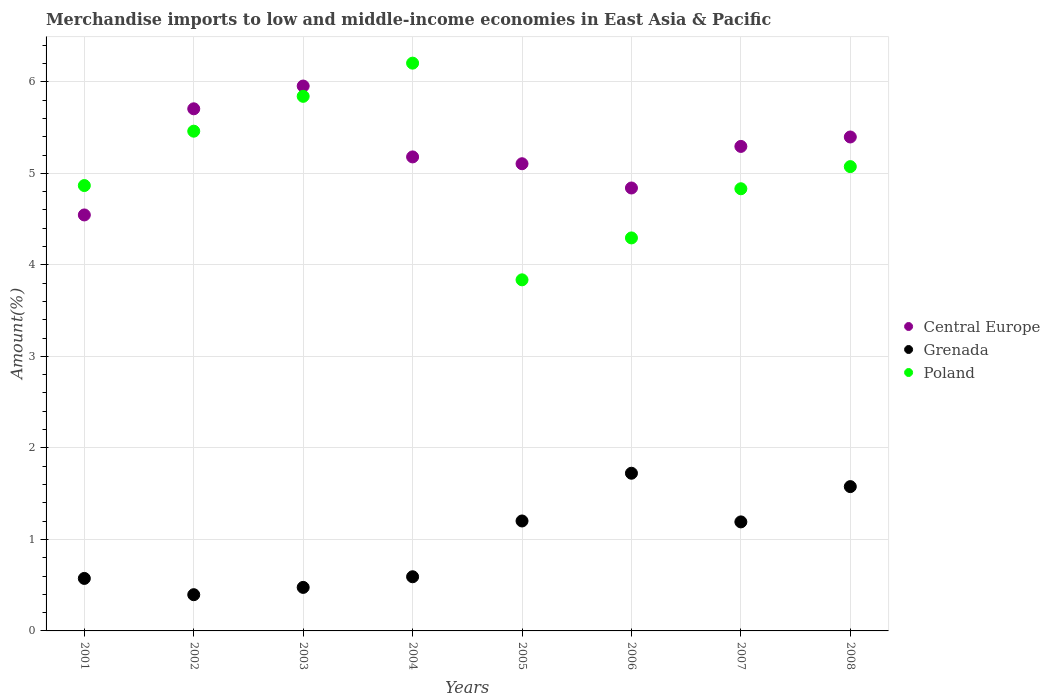How many different coloured dotlines are there?
Give a very brief answer. 3. What is the percentage of amount earned from merchandise imports in Grenada in 2005?
Offer a terse response. 1.2. Across all years, what is the maximum percentage of amount earned from merchandise imports in Poland?
Keep it short and to the point. 6.2. Across all years, what is the minimum percentage of amount earned from merchandise imports in Central Europe?
Give a very brief answer. 4.55. In which year was the percentage of amount earned from merchandise imports in Central Europe maximum?
Ensure brevity in your answer.  2003. What is the total percentage of amount earned from merchandise imports in Grenada in the graph?
Provide a succinct answer. 7.73. What is the difference between the percentage of amount earned from merchandise imports in Poland in 2005 and that in 2007?
Your answer should be compact. -1. What is the difference between the percentage of amount earned from merchandise imports in Central Europe in 2002 and the percentage of amount earned from merchandise imports in Poland in 2003?
Provide a short and direct response. -0.14. What is the average percentage of amount earned from merchandise imports in Grenada per year?
Your answer should be very brief. 0.97. In the year 2005, what is the difference between the percentage of amount earned from merchandise imports in Grenada and percentage of amount earned from merchandise imports in Central Europe?
Offer a terse response. -3.9. What is the ratio of the percentage of amount earned from merchandise imports in Poland in 2003 to that in 2008?
Give a very brief answer. 1.15. Is the percentage of amount earned from merchandise imports in Central Europe in 2001 less than that in 2005?
Keep it short and to the point. Yes. What is the difference between the highest and the second highest percentage of amount earned from merchandise imports in Poland?
Provide a short and direct response. 0.36. What is the difference between the highest and the lowest percentage of amount earned from merchandise imports in Central Europe?
Give a very brief answer. 1.41. In how many years, is the percentage of amount earned from merchandise imports in Central Europe greater than the average percentage of amount earned from merchandise imports in Central Europe taken over all years?
Offer a very short reply. 4. Is the sum of the percentage of amount earned from merchandise imports in Poland in 2001 and 2003 greater than the maximum percentage of amount earned from merchandise imports in Central Europe across all years?
Your answer should be very brief. Yes. Does the percentage of amount earned from merchandise imports in Poland monotonically increase over the years?
Ensure brevity in your answer.  No. Is the percentage of amount earned from merchandise imports in Grenada strictly greater than the percentage of amount earned from merchandise imports in Poland over the years?
Make the answer very short. No. Are the values on the major ticks of Y-axis written in scientific E-notation?
Your response must be concise. No. Does the graph contain any zero values?
Keep it short and to the point. No. How many legend labels are there?
Your answer should be compact. 3. What is the title of the graph?
Your answer should be compact. Merchandise imports to low and middle-income economies in East Asia & Pacific. What is the label or title of the Y-axis?
Provide a short and direct response. Amount(%). What is the Amount(%) in Central Europe in 2001?
Give a very brief answer. 4.55. What is the Amount(%) of Grenada in 2001?
Your answer should be compact. 0.57. What is the Amount(%) of Poland in 2001?
Your answer should be compact. 4.87. What is the Amount(%) of Central Europe in 2002?
Your answer should be very brief. 5.71. What is the Amount(%) in Grenada in 2002?
Offer a very short reply. 0.4. What is the Amount(%) of Poland in 2002?
Make the answer very short. 5.46. What is the Amount(%) of Central Europe in 2003?
Give a very brief answer. 5.95. What is the Amount(%) of Grenada in 2003?
Give a very brief answer. 0.48. What is the Amount(%) of Poland in 2003?
Your answer should be very brief. 5.84. What is the Amount(%) in Central Europe in 2004?
Give a very brief answer. 5.18. What is the Amount(%) of Grenada in 2004?
Make the answer very short. 0.59. What is the Amount(%) in Poland in 2004?
Ensure brevity in your answer.  6.2. What is the Amount(%) in Central Europe in 2005?
Make the answer very short. 5.1. What is the Amount(%) in Grenada in 2005?
Give a very brief answer. 1.2. What is the Amount(%) in Poland in 2005?
Your answer should be very brief. 3.84. What is the Amount(%) in Central Europe in 2006?
Ensure brevity in your answer.  4.84. What is the Amount(%) in Grenada in 2006?
Give a very brief answer. 1.72. What is the Amount(%) of Poland in 2006?
Ensure brevity in your answer.  4.29. What is the Amount(%) in Central Europe in 2007?
Keep it short and to the point. 5.29. What is the Amount(%) of Grenada in 2007?
Offer a terse response. 1.19. What is the Amount(%) of Poland in 2007?
Provide a succinct answer. 4.83. What is the Amount(%) in Central Europe in 2008?
Give a very brief answer. 5.4. What is the Amount(%) in Grenada in 2008?
Make the answer very short. 1.58. What is the Amount(%) in Poland in 2008?
Offer a very short reply. 5.07. Across all years, what is the maximum Amount(%) in Central Europe?
Offer a terse response. 5.95. Across all years, what is the maximum Amount(%) in Grenada?
Ensure brevity in your answer.  1.72. Across all years, what is the maximum Amount(%) of Poland?
Your answer should be very brief. 6.2. Across all years, what is the minimum Amount(%) of Central Europe?
Offer a very short reply. 4.55. Across all years, what is the minimum Amount(%) in Grenada?
Make the answer very short. 0.4. Across all years, what is the minimum Amount(%) in Poland?
Your answer should be very brief. 3.84. What is the total Amount(%) of Central Europe in the graph?
Make the answer very short. 42.02. What is the total Amount(%) in Grenada in the graph?
Provide a succinct answer. 7.73. What is the total Amount(%) in Poland in the graph?
Give a very brief answer. 40.41. What is the difference between the Amount(%) of Central Europe in 2001 and that in 2002?
Your answer should be very brief. -1.16. What is the difference between the Amount(%) of Grenada in 2001 and that in 2002?
Your answer should be very brief. 0.18. What is the difference between the Amount(%) in Poland in 2001 and that in 2002?
Keep it short and to the point. -0.59. What is the difference between the Amount(%) in Central Europe in 2001 and that in 2003?
Your response must be concise. -1.41. What is the difference between the Amount(%) in Grenada in 2001 and that in 2003?
Your response must be concise. 0.1. What is the difference between the Amount(%) of Poland in 2001 and that in 2003?
Your response must be concise. -0.97. What is the difference between the Amount(%) in Central Europe in 2001 and that in 2004?
Provide a succinct answer. -0.63. What is the difference between the Amount(%) in Grenada in 2001 and that in 2004?
Provide a short and direct response. -0.02. What is the difference between the Amount(%) of Poland in 2001 and that in 2004?
Your answer should be compact. -1.34. What is the difference between the Amount(%) in Central Europe in 2001 and that in 2005?
Provide a short and direct response. -0.56. What is the difference between the Amount(%) of Grenada in 2001 and that in 2005?
Provide a succinct answer. -0.63. What is the difference between the Amount(%) of Poland in 2001 and that in 2005?
Ensure brevity in your answer.  1.03. What is the difference between the Amount(%) of Central Europe in 2001 and that in 2006?
Provide a succinct answer. -0.29. What is the difference between the Amount(%) of Grenada in 2001 and that in 2006?
Your response must be concise. -1.15. What is the difference between the Amount(%) of Poland in 2001 and that in 2006?
Ensure brevity in your answer.  0.57. What is the difference between the Amount(%) in Central Europe in 2001 and that in 2007?
Offer a terse response. -0.75. What is the difference between the Amount(%) in Grenada in 2001 and that in 2007?
Your response must be concise. -0.62. What is the difference between the Amount(%) in Poland in 2001 and that in 2007?
Provide a short and direct response. 0.04. What is the difference between the Amount(%) in Central Europe in 2001 and that in 2008?
Your answer should be very brief. -0.85. What is the difference between the Amount(%) of Grenada in 2001 and that in 2008?
Make the answer very short. -1. What is the difference between the Amount(%) of Poland in 2001 and that in 2008?
Offer a very short reply. -0.21. What is the difference between the Amount(%) of Central Europe in 2002 and that in 2003?
Offer a terse response. -0.25. What is the difference between the Amount(%) in Grenada in 2002 and that in 2003?
Ensure brevity in your answer.  -0.08. What is the difference between the Amount(%) in Poland in 2002 and that in 2003?
Keep it short and to the point. -0.38. What is the difference between the Amount(%) in Central Europe in 2002 and that in 2004?
Your answer should be very brief. 0.53. What is the difference between the Amount(%) in Grenada in 2002 and that in 2004?
Offer a very short reply. -0.2. What is the difference between the Amount(%) of Poland in 2002 and that in 2004?
Make the answer very short. -0.74. What is the difference between the Amount(%) of Central Europe in 2002 and that in 2005?
Your answer should be very brief. 0.6. What is the difference between the Amount(%) in Grenada in 2002 and that in 2005?
Your response must be concise. -0.81. What is the difference between the Amount(%) of Poland in 2002 and that in 2005?
Offer a terse response. 1.62. What is the difference between the Amount(%) in Central Europe in 2002 and that in 2006?
Your answer should be compact. 0.87. What is the difference between the Amount(%) of Grenada in 2002 and that in 2006?
Make the answer very short. -1.33. What is the difference between the Amount(%) in Poland in 2002 and that in 2006?
Provide a short and direct response. 1.17. What is the difference between the Amount(%) in Central Europe in 2002 and that in 2007?
Offer a terse response. 0.41. What is the difference between the Amount(%) in Grenada in 2002 and that in 2007?
Provide a short and direct response. -0.8. What is the difference between the Amount(%) of Poland in 2002 and that in 2007?
Your response must be concise. 0.63. What is the difference between the Amount(%) in Central Europe in 2002 and that in 2008?
Your response must be concise. 0.31. What is the difference between the Amount(%) in Grenada in 2002 and that in 2008?
Make the answer very short. -1.18. What is the difference between the Amount(%) of Poland in 2002 and that in 2008?
Provide a succinct answer. 0.39. What is the difference between the Amount(%) of Central Europe in 2003 and that in 2004?
Make the answer very short. 0.77. What is the difference between the Amount(%) of Grenada in 2003 and that in 2004?
Your answer should be compact. -0.12. What is the difference between the Amount(%) of Poland in 2003 and that in 2004?
Give a very brief answer. -0.36. What is the difference between the Amount(%) of Central Europe in 2003 and that in 2005?
Provide a succinct answer. 0.85. What is the difference between the Amount(%) in Grenada in 2003 and that in 2005?
Make the answer very short. -0.73. What is the difference between the Amount(%) of Poland in 2003 and that in 2005?
Your answer should be compact. 2.01. What is the difference between the Amount(%) of Central Europe in 2003 and that in 2006?
Ensure brevity in your answer.  1.11. What is the difference between the Amount(%) in Grenada in 2003 and that in 2006?
Make the answer very short. -1.25. What is the difference between the Amount(%) in Poland in 2003 and that in 2006?
Provide a short and direct response. 1.55. What is the difference between the Amount(%) of Central Europe in 2003 and that in 2007?
Your answer should be compact. 0.66. What is the difference between the Amount(%) in Grenada in 2003 and that in 2007?
Ensure brevity in your answer.  -0.72. What is the difference between the Amount(%) of Poland in 2003 and that in 2007?
Provide a succinct answer. 1.01. What is the difference between the Amount(%) in Central Europe in 2003 and that in 2008?
Offer a terse response. 0.56. What is the difference between the Amount(%) of Grenada in 2003 and that in 2008?
Give a very brief answer. -1.1. What is the difference between the Amount(%) in Poland in 2003 and that in 2008?
Your answer should be very brief. 0.77. What is the difference between the Amount(%) in Central Europe in 2004 and that in 2005?
Keep it short and to the point. 0.07. What is the difference between the Amount(%) of Grenada in 2004 and that in 2005?
Provide a succinct answer. -0.61. What is the difference between the Amount(%) in Poland in 2004 and that in 2005?
Provide a short and direct response. 2.37. What is the difference between the Amount(%) of Central Europe in 2004 and that in 2006?
Provide a short and direct response. 0.34. What is the difference between the Amount(%) in Grenada in 2004 and that in 2006?
Ensure brevity in your answer.  -1.13. What is the difference between the Amount(%) in Poland in 2004 and that in 2006?
Offer a terse response. 1.91. What is the difference between the Amount(%) in Central Europe in 2004 and that in 2007?
Offer a very short reply. -0.11. What is the difference between the Amount(%) in Grenada in 2004 and that in 2007?
Provide a succinct answer. -0.6. What is the difference between the Amount(%) of Poland in 2004 and that in 2007?
Keep it short and to the point. 1.37. What is the difference between the Amount(%) in Central Europe in 2004 and that in 2008?
Your answer should be compact. -0.22. What is the difference between the Amount(%) in Grenada in 2004 and that in 2008?
Give a very brief answer. -0.99. What is the difference between the Amount(%) in Poland in 2004 and that in 2008?
Ensure brevity in your answer.  1.13. What is the difference between the Amount(%) in Central Europe in 2005 and that in 2006?
Ensure brevity in your answer.  0.27. What is the difference between the Amount(%) of Grenada in 2005 and that in 2006?
Provide a short and direct response. -0.52. What is the difference between the Amount(%) in Poland in 2005 and that in 2006?
Your answer should be compact. -0.46. What is the difference between the Amount(%) of Central Europe in 2005 and that in 2007?
Your response must be concise. -0.19. What is the difference between the Amount(%) in Grenada in 2005 and that in 2007?
Keep it short and to the point. 0.01. What is the difference between the Amount(%) in Poland in 2005 and that in 2007?
Offer a very short reply. -1. What is the difference between the Amount(%) in Central Europe in 2005 and that in 2008?
Offer a very short reply. -0.29. What is the difference between the Amount(%) in Grenada in 2005 and that in 2008?
Make the answer very short. -0.38. What is the difference between the Amount(%) of Poland in 2005 and that in 2008?
Give a very brief answer. -1.24. What is the difference between the Amount(%) of Central Europe in 2006 and that in 2007?
Provide a short and direct response. -0.45. What is the difference between the Amount(%) in Grenada in 2006 and that in 2007?
Offer a very short reply. 0.53. What is the difference between the Amount(%) of Poland in 2006 and that in 2007?
Keep it short and to the point. -0.54. What is the difference between the Amount(%) of Central Europe in 2006 and that in 2008?
Offer a terse response. -0.56. What is the difference between the Amount(%) in Grenada in 2006 and that in 2008?
Make the answer very short. 0.15. What is the difference between the Amount(%) of Poland in 2006 and that in 2008?
Provide a succinct answer. -0.78. What is the difference between the Amount(%) in Central Europe in 2007 and that in 2008?
Ensure brevity in your answer.  -0.1. What is the difference between the Amount(%) in Grenada in 2007 and that in 2008?
Provide a short and direct response. -0.39. What is the difference between the Amount(%) in Poland in 2007 and that in 2008?
Your answer should be compact. -0.24. What is the difference between the Amount(%) of Central Europe in 2001 and the Amount(%) of Grenada in 2002?
Give a very brief answer. 4.15. What is the difference between the Amount(%) in Central Europe in 2001 and the Amount(%) in Poland in 2002?
Your response must be concise. -0.92. What is the difference between the Amount(%) of Grenada in 2001 and the Amount(%) of Poland in 2002?
Keep it short and to the point. -4.89. What is the difference between the Amount(%) in Central Europe in 2001 and the Amount(%) in Grenada in 2003?
Your answer should be very brief. 4.07. What is the difference between the Amount(%) in Central Europe in 2001 and the Amount(%) in Poland in 2003?
Ensure brevity in your answer.  -1.3. What is the difference between the Amount(%) in Grenada in 2001 and the Amount(%) in Poland in 2003?
Ensure brevity in your answer.  -5.27. What is the difference between the Amount(%) in Central Europe in 2001 and the Amount(%) in Grenada in 2004?
Make the answer very short. 3.95. What is the difference between the Amount(%) of Central Europe in 2001 and the Amount(%) of Poland in 2004?
Provide a short and direct response. -1.66. What is the difference between the Amount(%) in Grenada in 2001 and the Amount(%) in Poland in 2004?
Your answer should be compact. -5.63. What is the difference between the Amount(%) of Central Europe in 2001 and the Amount(%) of Grenada in 2005?
Offer a very short reply. 3.34. What is the difference between the Amount(%) in Central Europe in 2001 and the Amount(%) in Poland in 2005?
Offer a terse response. 0.71. What is the difference between the Amount(%) of Grenada in 2001 and the Amount(%) of Poland in 2005?
Ensure brevity in your answer.  -3.26. What is the difference between the Amount(%) of Central Europe in 2001 and the Amount(%) of Grenada in 2006?
Keep it short and to the point. 2.82. What is the difference between the Amount(%) in Central Europe in 2001 and the Amount(%) in Poland in 2006?
Provide a short and direct response. 0.25. What is the difference between the Amount(%) in Grenada in 2001 and the Amount(%) in Poland in 2006?
Ensure brevity in your answer.  -3.72. What is the difference between the Amount(%) in Central Europe in 2001 and the Amount(%) in Grenada in 2007?
Your response must be concise. 3.35. What is the difference between the Amount(%) in Central Europe in 2001 and the Amount(%) in Poland in 2007?
Provide a succinct answer. -0.29. What is the difference between the Amount(%) in Grenada in 2001 and the Amount(%) in Poland in 2007?
Give a very brief answer. -4.26. What is the difference between the Amount(%) of Central Europe in 2001 and the Amount(%) of Grenada in 2008?
Your response must be concise. 2.97. What is the difference between the Amount(%) of Central Europe in 2001 and the Amount(%) of Poland in 2008?
Provide a succinct answer. -0.53. What is the difference between the Amount(%) in Grenada in 2001 and the Amount(%) in Poland in 2008?
Your answer should be compact. -4.5. What is the difference between the Amount(%) in Central Europe in 2002 and the Amount(%) in Grenada in 2003?
Give a very brief answer. 5.23. What is the difference between the Amount(%) of Central Europe in 2002 and the Amount(%) of Poland in 2003?
Provide a short and direct response. -0.14. What is the difference between the Amount(%) in Grenada in 2002 and the Amount(%) in Poland in 2003?
Give a very brief answer. -5.45. What is the difference between the Amount(%) in Central Europe in 2002 and the Amount(%) in Grenada in 2004?
Make the answer very short. 5.11. What is the difference between the Amount(%) of Central Europe in 2002 and the Amount(%) of Poland in 2004?
Provide a short and direct response. -0.5. What is the difference between the Amount(%) of Grenada in 2002 and the Amount(%) of Poland in 2004?
Give a very brief answer. -5.81. What is the difference between the Amount(%) in Central Europe in 2002 and the Amount(%) in Grenada in 2005?
Offer a terse response. 4.5. What is the difference between the Amount(%) in Central Europe in 2002 and the Amount(%) in Poland in 2005?
Provide a succinct answer. 1.87. What is the difference between the Amount(%) of Grenada in 2002 and the Amount(%) of Poland in 2005?
Give a very brief answer. -3.44. What is the difference between the Amount(%) of Central Europe in 2002 and the Amount(%) of Grenada in 2006?
Make the answer very short. 3.98. What is the difference between the Amount(%) of Central Europe in 2002 and the Amount(%) of Poland in 2006?
Your answer should be compact. 1.41. What is the difference between the Amount(%) in Grenada in 2002 and the Amount(%) in Poland in 2006?
Keep it short and to the point. -3.9. What is the difference between the Amount(%) in Central Europe in 2002 and the Amount(%) in Grenada in 2007?
Your response must be concise. 4.51. What is the difference between the Amount(%) in Central Europe in 2002 and the Amount(%) in Poland in 2007?
Make the answer very short. 0.87. What is the difference between the Amount(%) in Grenada in 2002 and the Amount(%) in Poland in 2007?
Your response must be concise. -4.44. What is the difference between the Amount(%) of Central Europe in 2002 and the Amount(%) of Grenada in 2008?
Offer a very short reply. 4.13. What is the difference between the Amount(%) in Central Europe in 2002 and the Amount(%) in Poland in 2008?
Keep it short and to the point. 0.63. What is the difference between the Amount(%) of Grenada in 2002 and the Amount(%) of Poland in 2008?
Make the answer very short. -4.68. What is the difference between the Amount(%) in Central Europe in 2003 and the Amount(%) in Grenada in 2004?
Your answer should be very brief. 5.36. What is the difference between the Amount(%) in Central Europe in 2003 and the Amount(%) in Poland in 2004?
Make the answer very short. -0.25. What is the difference between the Amount(%) in Grenada in 2003 and the Amount(%) in Poland in 2004?
Provide a short and direct response. -5.73. What is the difference between the Amount(%) in Central Europe in 2003 and the Amount(%) in Grenada in 2005?
Give a very brief answer. 4.75. What is the difference between the Amount(%) of Central Europe in 2003 and the Amount(%) of Poland in 2005?
Your answer should be compact. 2.12. What is the difference between the Amount(%) in Grenada in 2003 and the Amount(%) in Poland in 2005?
Offer a terse response. -3.36. What is the difference between the Amount(%) in Central Europe in 2003 and the Amount(%) in Grenada in 2006?
Offer a very short reply. 4.23. What is the difference between the Amount(%) of Central Europe in 2003 and the Amount(%) of Poland in 2006?
Offer a terse response. 1.66. What is the difference between the Amount(%) of Grenada in 2003 and the Amount(%) of Poland in 2006?
Provide a succinct answer. -3.82. What is the difference between the Amount(%) of Central Europe in 2003 and the Amount(%) of Grenada in 2007?
Your answer should be compact. 4.76. What is the difference between the Amount(%) of Central Europe in 2003 and the Amount(%) of Poland in 2007?
Offer a terse response. 1.12. What is the difference between the Amount(%) in Grenada in 2003 and the Amount(%) in Poland in 2007?
Your response must be concise. -4.36. What is the difference between the Amount(%) of Central Europe in 2003 and the Amount(%) of Grenada in 2008?
Keep it short and to the point. 4.38. What is the difference between the Amount(%) of Central Europe in 2003 and the Amount(%) of Poland in 2008?
Offer a very short reply. 0.88. What is the difference between the Amount(%) in Grenada in 2003 and the Amount(%) in Poland in 2008?
Offer a very short reply. -4.6. What is the difference between the Amount(%) of Central Europe in 2004 and the Amount(%) of Grenada in 2005?
Offer a very short reply. 3.98. What is the difference between the Amount(%) of Central Europe in 2004 and the Amount(%) of Poland in 2005?
Give a very brief answer. 1.34. What is the difference between the Amount(%) of Grenada in 2004 and the Amount(%) of Poland in 2005?
Ensure brevity in your answer.  -3.24. What is the difference between the Amount(%) in Central Europe in 2004 and the Amount(%) in Grenada in 2006?
Your response must be concise. 3.46. What is the difference between the Amount(%) in Central Europe in 2004 and the Amount(%) in Poland in 2006?
Your response must be concise. 0.89. What is the difference between the Amount(%) of Grenada in 2004 and the Amount(%) of Poland in 2006?
Your answer should be compact. -3.7. What is the difference between the Amount(%) of Central Europe in 2004 and the Amount(%) of Grenada in 2007?
Provide a short and direct response. 3.99. What is the difference between the Amount(%) in Central Europe in 2004 and the Amount(%) in Poland in 2007?
Your answer should be very brief. 0.35. What is the difference between the Amount(%) of Grenada in 2004 and the Amount(%) of Poland in 2007?
Keep it short and to the point. -4.24. What is the difference between the Amount(%) of Central Europe in 2004 and the Amount(%) of Grenada in 2008?
Your response must be concise. 3.6. What is the difference between the Amount(%) in Central Europe in 2004 and the Amount(%) in Poland in 2008?
Provide a succinct answer. 0.11. What is the difference between the Amount(%) in Grenada in 2004 and the Amount(%) in Poland in 2008?
Offer a terse response. -4.48. What is the difference between the Amount(%) in Central Europe in 2005 and the Amount(%) in Grenada in 2006?
Make the answer very short. 3.38. What is the difference between the Amount(%) of Central Europe in 2005 and the Amount(%) of Poland in 2006?
Ensure brevity in your answer.  0.81. What is the difference between the Amount(%) of Grenada in 2005 and the Amount(%) of Poland in 2006?
Ensure brevity in your answer.  -3.09. What is the difference between the Amount(%) of Central Europe in 2005 and the Amount(%) of Grenada in 2007?
Keep it short and to the point. 3.91. What is the difference between the Amount(%) of Central Europe in 2005 and the Amount(%) of Poland in 2007?
Make the answer very short. 0.27. What is the difference between the Amount(%) in Grenada in 2005 and the Amount(%) in Poland in 2007?
Ensure brevity in your answer.  -3.63. What is the difference between the Amount(%) of Central Europe in 2005 and the Amount(%) of Grenada in 2008?
Your answer should be compact. 3.53. What is the difference between the Amount(%) in Central Europe in 2005 and the Amount(%) in Poland in 2008?
Provide a short and direct response. 0.03. What is the difference between the Amount(%) in Grenada in 2005 and the Amount(%) in Poland in 2008?
Your response must be concise. -3.87. What is the difference between the Amount(%) in Central Europe in 2006 and the Amount(%) in Grenada in 2007?
Keep it short and to the point. 3.65. What is the difference between the Amount(%) of Central Europe in 2006 and the Amount(%) of Poland in 2007?
Your answer should be very brief. 0.01. What is the difference between the Amount(%) in Grenada in 2006 and the Amount(%) in Poland in 2007?
Your answer should be compact. -3.11. What is the difference between the Amount(%) in Central Europe in 2006 and the Amount(%) in Grenada in 2008?
Give a very brief answer. 3.26. What is the difference between the Amount(%) of Central Europe in 2006 and the Amount(%) of Poland in 2008?
Offer a terse response. -0.23. What is the difference between the Amount(%) of Grenada in 2006 and the Amount(%) of Poland in 2008?
Provide a short and direct response. -3.35. What is the difference between the Amount(%) of Central Europe in 2007 and the Amount(%) of Grenada in 2008?
Keep it short and to the point. 3.72. What is the difference between the Amount(%) of Central Europe in 2007 and the Amount(%) of Poland in 2008?
Your response must be concise. 0.22. What is the difference between the Amount(%) in Grenada in 2007 and the Amount(%) in Poland in 2008?
Give a very brief answer. -3.88. What is the average Amount(%) of Central Europe per year?
Make the answer very short. 5.25. What is the average Amount(%) in Grenada per year?
Provide a succinct answer. 0.97. What is the average Amount(%) in Poland per year?
Keep it short and to the point. 5.05. In the year 2001, what is the difference between the Amount(%) of Central Europe and Amount(%) of Grenada?
Ensure brevity in your answer.  3.97. In the year 2001, what is the difference between the Amount(%) of Central Europe and Amount(%) of Poland?
Your response must be concise. -0.32. In the year 2001, what is the difference between the Amount(%) in Grenada and Amount(%) in Poland?
Provide a succinct answer. -4.29. In the year 2002, what is the difference between the Amount(%) of Central Europe and Amount(%) of Grenada?
Your answer should be very brief. 5.31. In the year 2002, what is the difference between the Amount(%) in Central Europe and Amount(%) in Poland?
Offer a terse response. 0.24. In the year 2002, what is the difference between the Amount(%) in Grenada and Amount(%) in Poland?
Provide a short and direct response. -5.06. In the year 2003, what is the difference between the Amount(%) of Central Europe and Amount(%) of Grenada?
Your answer should be compact. 5.48. In the year 2003, what is the difference between the Amount(%) in Central Europe and Amount(%) in Poland?
Your answer should be very brief. 0.11. In the year 2003, what is the difference between the Amount(%) of Grenada and Amount(%) of Poland?
Your answer should be very brief. -5.37. In the year 2004, what is the difference between the Amount(%) of Central Europe and Amount(%) of Grenada?
Ensure brevity in your answer.  4.59. In the year 2004, what is the difference between the Amount(%) in Central Europe and Amount(%) in Poland?
Your response must be concise. -1.02. In the year 2004, what is the difference between the Amount(%) of Grenada and Amount(%) of Poland?
Provide a succinct answer. -5.61. In the year 2005, what is the difference between the Amount(%) of Central Europe and Amount(%) of Grenada?
Make the answer very short. 3.9. In the year 2005, what is the difference between the Amount(%) of Central Europe and Amount(%) of Poland?
Offer a terse response. 1.27. In the year 2005, what is the difference between the Amount(%) of Grenada and Amount(%) of Poland?
Keep it short and to the point. -2.63. In the year 2006, what is the difference between the Amount(%) of Central Europe and Amount(%) of Grenada?
Give a very brief answer. 3.12. In the year 2006, what is the difference between the Amount(%) of Central Europe and Amount(%) of Poland?
Offer a terse response. 0.55. In the year 2006, what is the difference between the Amount(%) of Grenada and Amount(%) of Poland?
Offer a very short reply. -2.57. In the year 2007, what is the difference between the Amount(%) in Central Europe and Amount(%) in Grenada?
Offer a very short reply. 4.1. In the year 2007, what is the difference between the Amount(%) of Central Europe and Amount(%) of Poland?
Ensure brevity in your answer.  0.46. In the year 2007, what is the difference between the Amount(%) in Grenada and Amount(%) in Poland?
Your answer should be compact. -3.64. In the year 2008, what is the difference between the Amount(%) in Central Europe and Amount(%) in Grenada?
Your answer should be very brief. 3.82. In the year 2008, what is the difference between the Amount(%) in Central Europe and Amount(%) in Poland?
Your answer should be compact. 0.32. In the year 2008, what is the difference between the Amount(%) of Grenada and Amount(%) of Poland?
Your answer should be compact. -3.5. What is the ratio of the Amount(%) in Central Europe in 2001 to that in 2002?
Keep it short and to the point. 0.8. What is the ratio of the Amount(%) in Grenada in 2001 to that in 2002?
Give a very brief answer. 1.45. What is the ratio of the Amount(%) in Poland in 2001 to that in 2002?
Your answer should be compact. 0.89. What is the ratio of the Amount(%) in Central Europe in 2001 to that in 2003?
Keep it short and to the point. 0.76. What is the ratio of the Amount(%) of Grenada in 2001 to that in 2003?
Provide a short and direct response. 1.21. What is the ratio of the Amount(%) of Poland in 2001 to that in 2003?
Give a very brief answer. 0.83. What is the ratio of the Amount(%) in Central Europe in 2001 to that in 2004?
Offer a very short reply. 0.88. What is the ratio of the Amount(%) in Grenada in 2001 to that in 2004?
Provide a short and direct response. 0.97. What is the ratio of the Amount(%) in Poland in 2001 to that in 2004?
Make the answer very short. 0.78. What is the ratio of the Amount(%) in Central Europe in 2001 to that in 2005?
Provide a succinct answer. 0.89. What is the ratio of the Amount(%) of Grenada in 2001 to that in 2005?
Provide a succinct answer. 0.48. What is the ratio of the Amount(%) of Poland in 2001 to that in 2005?
Your answer should be compact. 1.27. What is the ratio of the Amount(%) of Central Europe in 2001 to that in 2006?
Offer a very short reply. 0.94. What is the ratio of the Amount(%) in Grenada in 2001 to that in 2006?
Provide a short and direct response. 0.33. What is the ratio of the Amount(%) of Poland in 2001 to that in 2006?
Your answer should be compact. 1.13. What is the ratio of the Amount(%) in Central Europe in 2001 to that in 2007?
Your response must be concise. 0.86. What is the ratio of the Amount(%) in Grenada in 2001 to that in 2007?
Your response must be concise. 0.48. What is the ratio of the Amount(%) in Poland in 2001 to that in 2007?
Ensure brevity in your answer.  1.01. What is the ratio of the Amount(%) of Central Europe in 2001 to that in 2008?
Your answer should be compact. 0.84. What is the ratio of the Amount(%) in Grenada in 2001 to that in 2008?
Your answer should be very brief. 0.36. What is the ratio of the Amount(%) of Poland in 2001 to that in 2008?
Ensure brevity in your answer.  0.96. What is the ratio of the Amount(%) in Central Europe in 2002 to that in 2003?
Offer a terse response. 0.96. What is the ratio of the Amount(%) in Grenada in 2002 to that in 2003?
Provide a short and direct response. 0.83. What is the ratio of the Amount(%) of Poland in 2002 to that in 2003?
Your answer should be very brief. 0.93. What is the ratio of the Amount(%) of Central Europe in 2002 to that in 2004?
Give a very brief answer. 1.1. What is the ratio of the Amount(%) in Grenada in 2002 to that in 2004?
Make the answer very short. 0.67. What is the ratio of the Amount(%) of Poland in 2002 to that in 2004?
Ensure brevity in your answer.  0.88. What is the ratio of the Amount(%) in Central Europe in 2002 to that in 2005?
Your answer should be very brief. 1.12. What is the ratio of the Amount(%) in Grenada in 2002 to that in 2005?
Offer a terse response. 0.33. What is the ratio of the Amount(%) of Poland in 2002 to that in 2005?
Ensure brevity in your answer.  1.42. What is the ratio of the Amount(%) of Central Europe in 2002 to that in 2006?
Ensure brevity in your answer.  1.18. What is the ratio of the Amount(%) in Grenada in 2002 to that in 2006?
Your response must be concise. 0.23. What is the ratio of the Amount(%) of Poland in 2002 to that in 2006?
Offer a very short reply. 1.27. What is the ratio of the Amount(%) of Central Europe in 2002 to that in 2007?
Your response must be concise. 1.08. What is the ratio of the Amount(%) of Grenada in 2002 to that in 2007?
Ensure brevity in your answer.  0.33. What is the ratio of the Amount(%) in Poland in 2002 to that in 2007?
Provide a short and direct response. 1.13. What is the ratio of the Amount(%) of Central Europe in 2002 to that in 2008?
Your response must be concise. 1.06. What is the ratio of the Amount(%) of Grenada in 2002 to that in 2008?
Ensure brevity in your answer.  0.25. What is the ratio of the Amount(%) of Poland in 2002 to that in 2008?
Your answer should be compact. 1.08. What is the ratio of the Amount(%) in Central Europe in 2003 to that in 2004?
Keep it short and to the point. 1.15. What is the ratio of the Amount(%) in Grenada in 2003 to that in 2004?
Make the answer very short. 0.8. What is the ratio of the Amount(%) in Poland in 2003 to that in 2004?
Provide a succinct answer. 0.94. What is the ratio of the Amount(%) of Central Europe in 2003 to that in 2005?
Ensure brevity in your answer.  1.17. What is the ratio of the Amount(%) in Grenada in 2003 to that in 2005?
Offer a very short reply. 0.4. What is the ratio of the Amount(%) in Poland in 2003 to that in 2005?
Your response must be concise. 1.52. What is the ratio of the Amount(%) of Central Europe in 2003 to that in 2006?
Keep it short and to the point. 1.23. What is the ratio of the Amount(%) in Grenada in 2003 to that in 2006?
Ensure brevity in your answer.  0.28. What is the ratio of the Amount(%) in Poland in 2003 to that in 2006?
Your response must be concise. 1.36. What is the ratio of the Amount(%) in Central Europe in 2003 to that in 2007?
Your answer should be very brief. 1.12. What is the ratio of the Amount(%) of Grenada in 2003 to that in 2007?
Give a very brief answer. 0.4. What is the ratio of the Amount(%) of Poland in 2003 to that in 2007?
Offer a very short reply. 1.21. What is the ratio of the Amount(%) of Central Europe in 2003 to that in 2008?
Your answer should be compact. 1.1. What is the ratio of the Amount(%) of Grenada in 2003 to that in 2008?
Your answer should be very brief. 0.3. What is the ratio of the Amount(%) of Poland in 2003 to that in 2008?
Ensure brevity in your answer.  1.15. What is the ratio of the Amount(%) in Central Europe in 2004 to that in 2005?
Provide a succinct answer. 1.01. What is the ratio of the Amount(%) in Grenada in 2004 to that in 2005?
Your response must be concise. 0.49. What is the ratio of the Amount(%) in Poland in 2004 to that in 2005?
Give a very brief answer. 1.62. What is the ratio of the Amount(%) in Central Europe in 2004 to that in 2006?
Provide a succinct answer. 1.07. What is the ratio of the Amount(%) of Grenada in 2004 to that in 2006?
Give a very brief answer. 0.34. What is the ratio of the Amount(%) of Poland in 2004 to that in 2006?
Make the answer very short. 1.44. What is the ratio of the Amount(%) of Central Europe in 2004 to that in 2007?
Your answer should be very brief. 0.98. What is the ratio of the Amount(%) of Grenada in 2004 to that in 2007?
Your answer should be compact. 0.5. What is the ratio of the Amount(%) in Poland in 2004 to that in 2007?
Give a very brief answer. 1.28. What is the ratio of the Amount(%) of Central Europe in 2004 to that in 2008?
Offer a very short reply. 0.96. What is the ratio of the Amount(%) of Grenada in 2004 to that in 2008?
Your answer should be very brief. 0.38. What is the ratio of the Amount(%) of Poland in 2004 to that in 2008?
Your response must be concise. 1.22. What is the ratio of the Amount(%) in Central Europe in 2005 to that in 2006?
Offer a terse response. 1.05. What is the ratio of the Amount(%) of Grenada in 2005 to that in 2006?
Your response must be concise. 0.7. What is the ratio of the Amount(%) of Poland in 2005 to that in 2006?
Give a very brief answer. 0.89. What is the ratio of the Amount(%) in Grenada in 2005 to that in 2007?
Your response must be concise. 1.01. What is the ratio of the Amount(%) of Poland in 2005 to that in 2007?
Ensure brevity in your answer.  0.79. What is the ratio of the Amount(%) of Central Europe in 2005 to that in 2008?
Ensure brevity in your answer.  0.95. What is the ratio of the Amount(%) in Grenada in 2005 to that in 2008?
Keep it short and to the point. 0.76. What is the ratio of the Amount(%) of Poland in 2005 to that in 2008?
Ensure brevity in your answer.  0.76. What is the ratio of the Amount(%) in Central Europe in 2006 to that in 2007?
Keep it short and to the point. 0.91. What is the ratio of the Amount(%) of Grenada in 2006 to that in 2007?
Offer a terse response. 1.45. What is the ratio of the Amount(%) in Poland in 2006 to that in 2007?
Make the answer very short. 0.89. What is the ratio of the Amount(%) of Central Europe in 2006 to that in 2008?
Offer a very short reply. 0.9. What is the ratio of the Amount(%) of Grenada in 2006 to that in 2008?
Keep it short and to the point. 1.09. What is the ratio of the Amount(%) in Poland in 2006 to that in 2008?
Your answer should be very brief. 0.85. What is the ratio of the Amount(%) in Central Europe in 2007 to that in 2008?
Offer a very short reply. 0.98. What is the ratio of the Amount(%) of Grenada in 2007 to that in 2008?
Give a very brief answer. 0.76. What is the ratio of the Amount(%) in Poland in 2007 to that in 2008?
Keep it short and to the point. 0.95. What is the difference between the highest and the second highest Amount(%) of Central Europe?
Make the answer very short. 0.25. What is the difference between the highest and the second highest Amount(%) in Grenada?
Ensure brevity in your answer.  0.15. What is the difference between the highest and the second highest Amount(%) in Poland?
Provide a succinct answer. 0.36. What is the difference between the highest and the lowest Amount(%) of Central Europe?
Your answer should be very brief. 1.41. What is the difference between the highest and the lowest Amount(%) of Grenada?
Your response must be concise. 1.33. What is the difference between the highest and the lowest Amount(%) of Poland?
Make the answer very short. 2.37. 